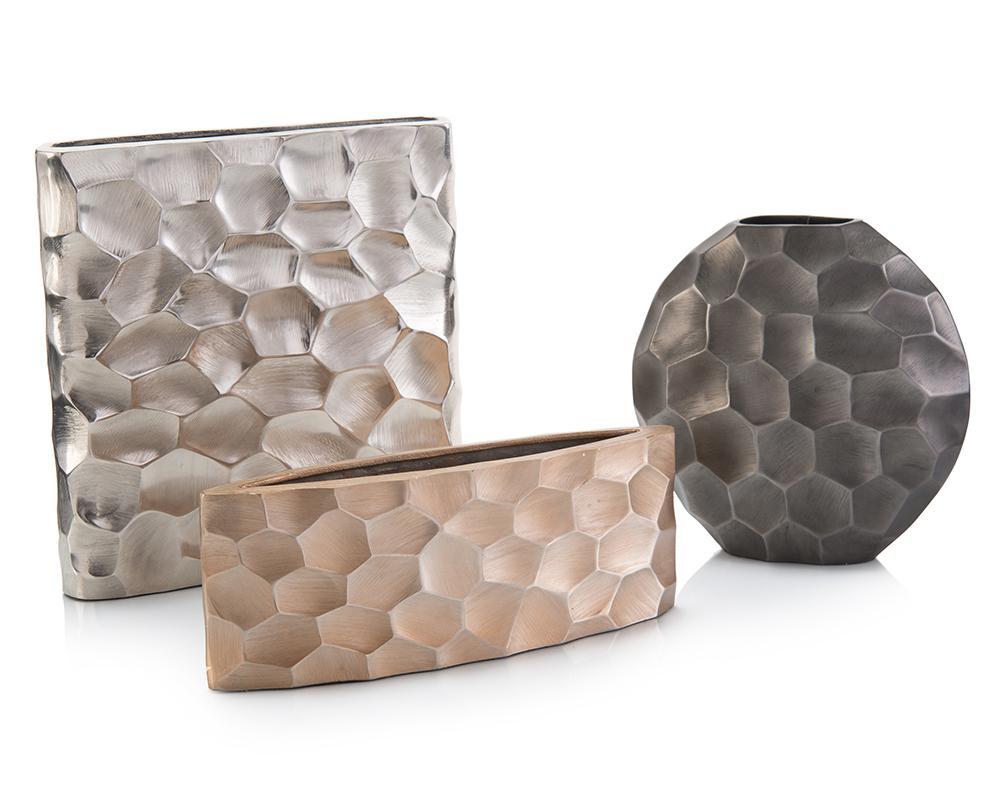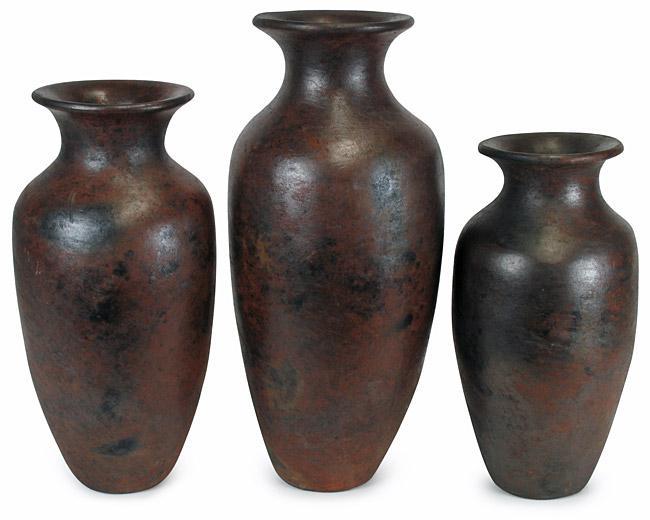The first image is the image on the left, the second image is the image on the right. Given the left and right images, does the statement "there are dark fluted vases and hammered textured ones" hold true? Answer yes or no. Yes. 